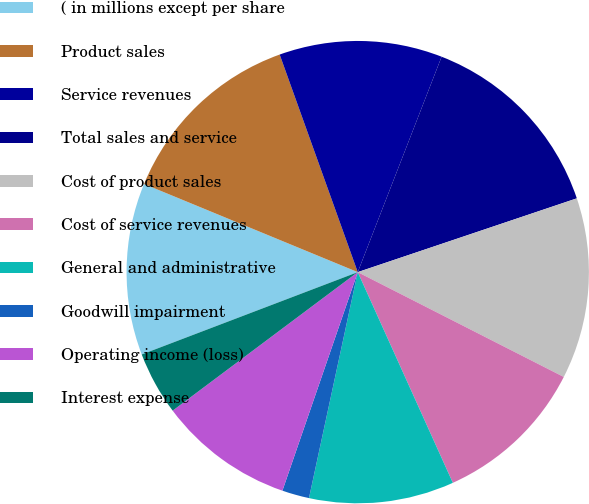<chart> <loc_0><loc_0><loc_500><loc_500><pie_chart><fcel>( in millions except per share<fcel>Product sales<fcel>Service revenues<fcel>Total sales and service<fcel>Cost of product sales<fcel>Cost of service revenues<fcel>General and administrative<fcel>Goodwill impairment<fcel>Operating income (loss)<fcel>Interest expense<nl><fcel>12.02%<fcel>13.29%<fcel>11.39%<fcel>13.92%<fcel>12.66%<fcel>10.76%<fcel>10.13%<fcel>1.9%<fcel>9.49%<fcel>4.43%<nl></chart> 